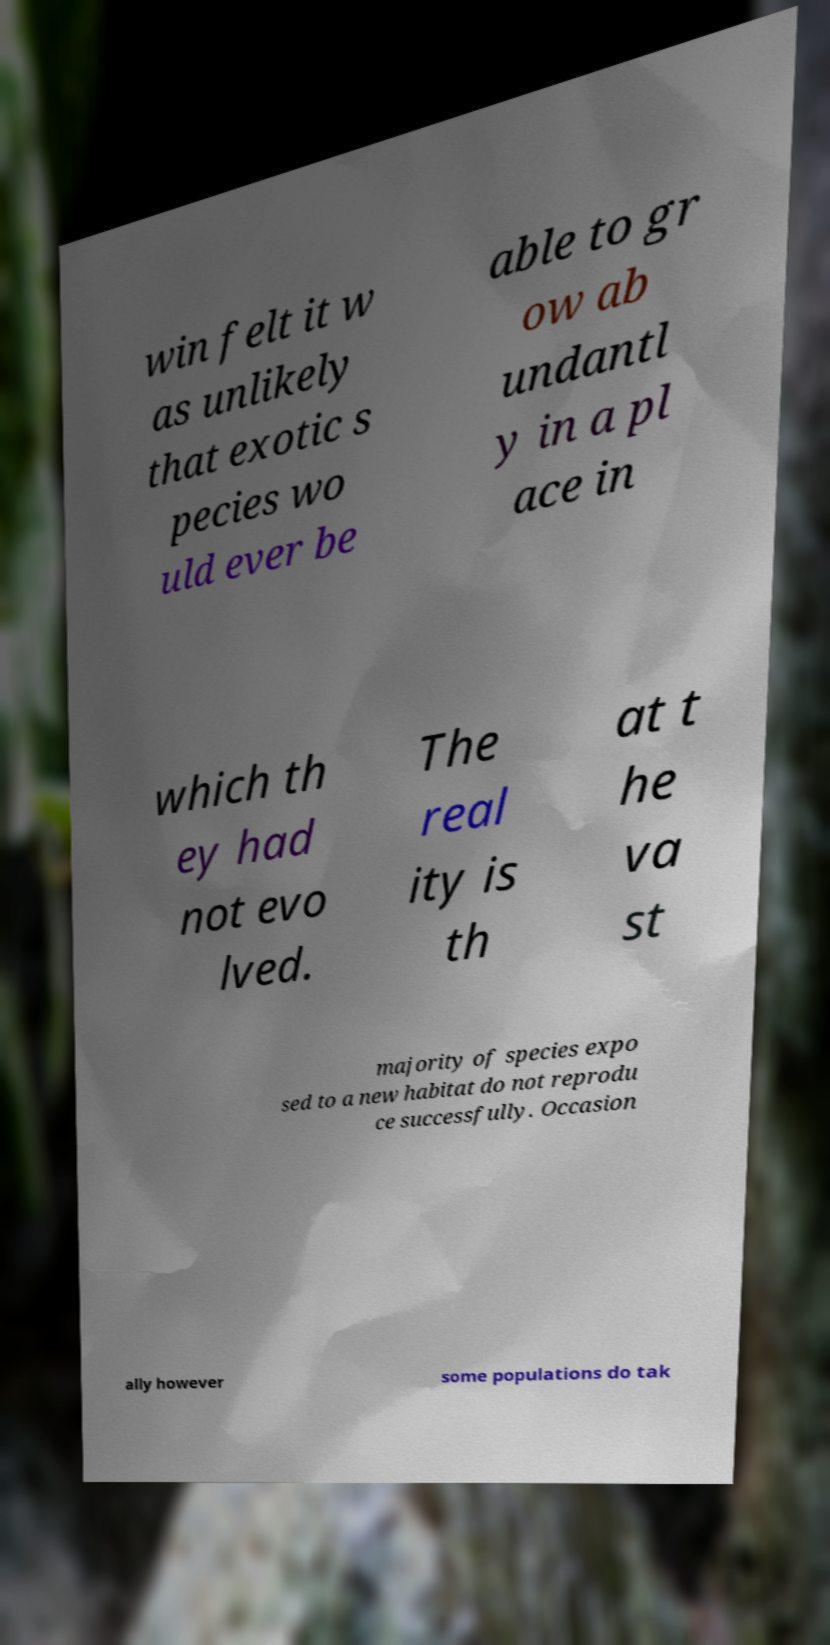Can you accurately transcribe the text from the provided image for me? win felt it w as unlikely that exotic s pecies wo uld ever be able to gr ow ab undantl y in a pl ace in which th ey had not evo lved. The real ity is th at t he va st majority of species expo sed to a new habitat do not reprodu ce successfully. Occasion ally however some populations do tak 